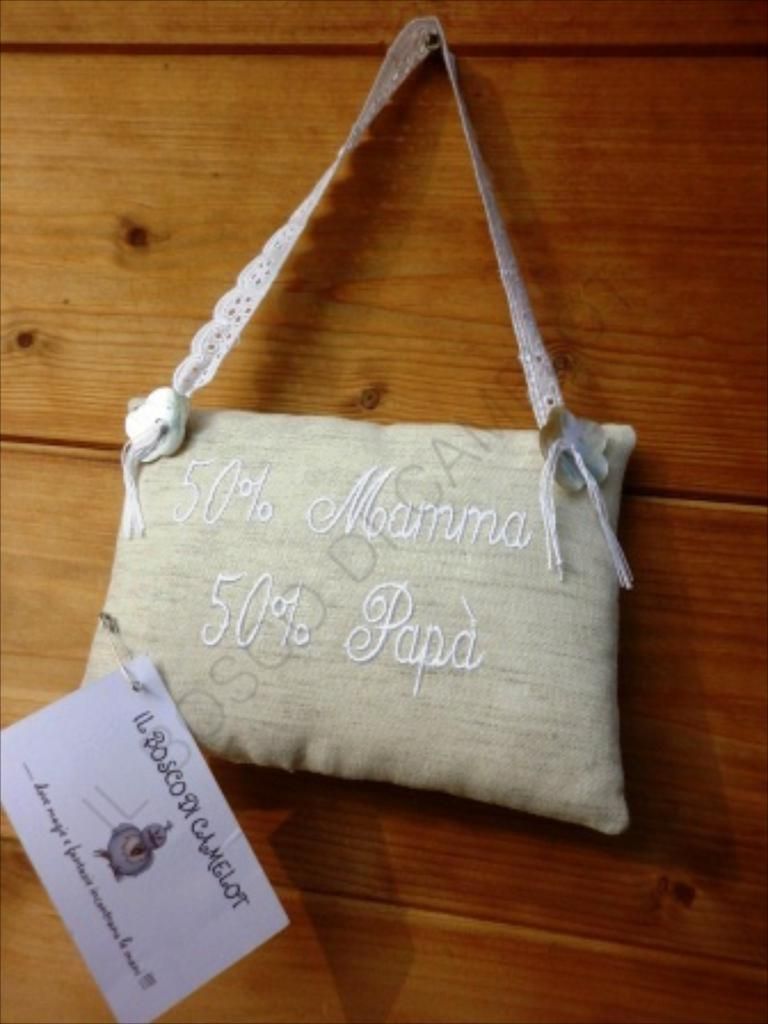What is the color of the purse in the image? The purse in the image is white in color. Where is the purse located in the image? The purse is hanging on a wall in the image. What is the color of the wall on which the purse is hanging? The wall is brown in color. Is there anything else on the purse in the image? Yes, there is a white color slip on the purse. What type of process is being carried out in the lunchroom in the image? There is no lunchroom or process depicted in the image; it only features a white color purse hanging on a brown wall with a white color slip on it. 